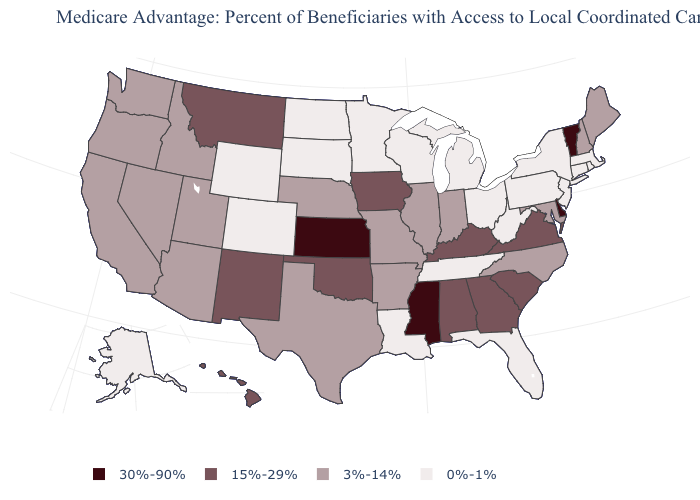Name the states that have a value in the range 0%-1%?
Quick response, please. Colorado, Connecticut, Florida, Louisiana, Massachusetts, Michigan, Minnesota, North Dakota, New Jersey, New York, Ohio, Pennsylvania, Rhode Island, South Dakota, Alaska, Tennessee, Wisconsin, West Virginia, Wyoming. Does the first symbol in the legend represent the smallest category?
Write a very short answer. No. Among the states that border Idaho , which have the lowest value?
Concise answer only. Wyoming. Name the states that have a value in the range 3%-14%?
Concise answer only. California, Idaho, Illinois, Indiana, Maryland, Maine, Missouri, North Carolina, Nebraska, New Hampshire, Nevada, Oregon, Texas, Utah, Washington, Arkansas, Arizona. Does Hawaii have the highest value in the West?
Keep it brief. Yes. Name the states that have a value in the range 3%-14%?
Give a very brief answer. California, Idaho, Illinois, Indiana, Maryland, Maine, Missouri, North Carolina, Nebraska, New Hampshire, Nevada, Oregon, Texas, Utah, Washington, Arkansas, Arizona. Does Ohio have the lowest value in the USA?
Write a very short answer. Yes. Name the states that have a value in the range 15%-29%?
Keep it brief. Georgia, Hawaii, Iowa, Kentucky, Montana, New Mexico, Oklahoma, South Carolina, Virginia, Alabama. Does Iowa have the lowest value in the USA?
Write a very short answer. No. What is the highest value in states that border Arizona?
Be succinct. 15%-29%. What is the highest value in the MidWest ?
Write a very short answer. 30%-90%. What is the value of North Dakota?
Give a very brief answer. 0%-1%. Does Massachusetts have the highest value in the Northeast?
Short answer required. No. Does Kansas have the highest value in the USA?
Be succinct. Yes. Name the states that have a value in the range 0%-1%?
Quick response, please. Colorado, Connecticut, Florida, Louisiana, Massachusetts, Michigan, Minnesota, North Dakota, New Jersey, New York, Ohio, Pennsylvania, Rhode Island, South Dakota, Alaska, Tennessee, Wisconsin, West Virginia, Wyoming. 